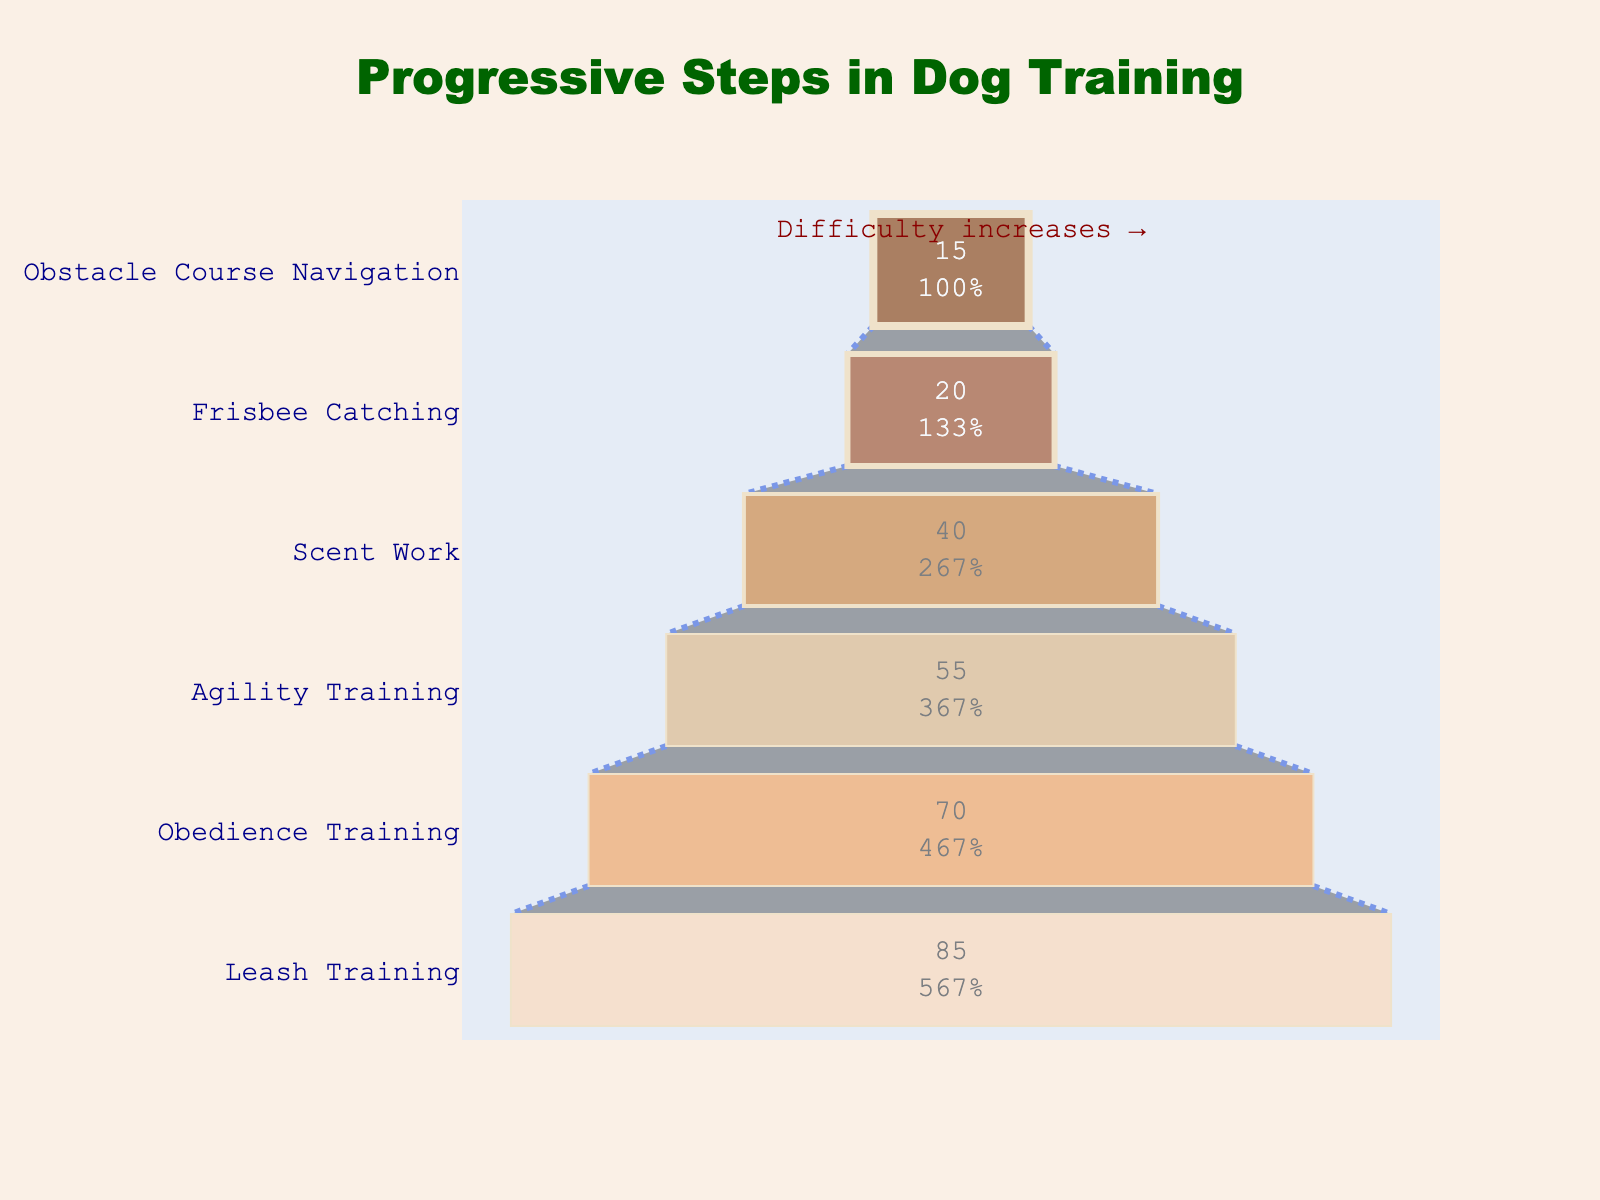What is the title of the chart? The title of the chart is shown prominently at the top and reads "Progressive Steps in Dog Training".
Answer: Progressive Steps in Dog Training How many training steps are shown in the chart? Count the number of distinct steps listed on the y-axis. There are six steps shown.
Answer: 6 Which step has the highest number of dogs successfully trained? From the x-axis, the first entry, "Leash Training," has the highest value of 85 dogs successfully trained.
Answer: Leash Training What is the difficulty level of Agility Training? The difficulty levels are listed in the data. For "Agility Training," the difficulty level is 4.
Answer: 4 Which step has the least number of dogs successfully trained? From the x-axis, the last entry, "Obstacle Course Navigation," has the lowest value of 15 dogs successfully trained.
Answer: Obstacle Course Navigation What is the percentage of dogs that successfully completed Scent Work relative to those that started with Leash Training? Calculate the percentage by taking the number of dogs who completed Scent Work (40) divided by those who started with Leash Training (85) and multiplying by 100: (40 / 85) * 100 ≈ 47%.
Answer: 47% Based on the chart, how does the number of dogs successfully trained for Obedience Training compare to Agility Training? Obedience Training has 70 dogs successfully trained, while Agility Training has 55 dogs. Since 70 is greater than 55, Obedience Training has more dogs successfully trained.
Answer: Obedience Training has more What is the combined total number of dogs that successfully completed Frisbee Catching and Scent Work? Add the number of dogs for Frisbee Catching (20) and Scent Work (40): 20 + 40 = 60.
Answer: 60 What is the trend in the number of dogs successfully trained as the difficulty level increases? Observing the x-axis values in relation to the y-axis steps, the number of dogs successfully trained decreases as the difficulty level increases.
Answer: Decreases How many more dogs were successfully trained in Leash Training compared to Frisbee Catching? Subtract the number of dogs successfully trained in Frisbee Catching (20) from those in Leash Training (85): 85 - 20 = 65.
Answer: 65 